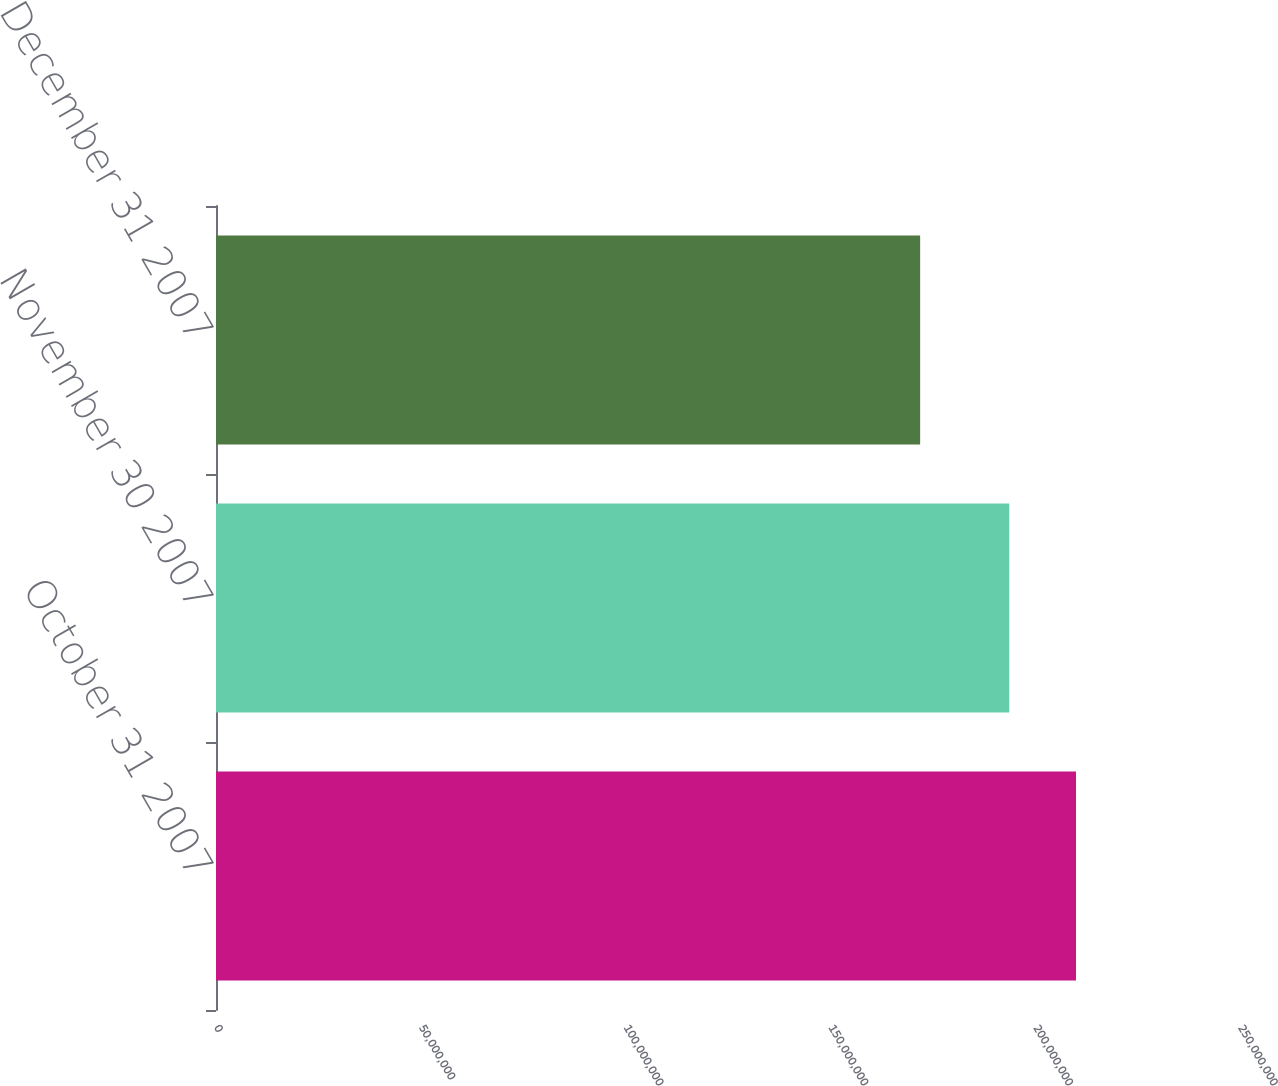Convert chart. <chart><loc_0><loc_0><loc_500><loc_500><bar_chart><fcel>October 31 2007<fcel>November 30 2007<fcel>December 31 2007<nl><fcel>2.0996e+08<fcel>1.9366e+08<fcel>1.7191e+08<nl></chart> 